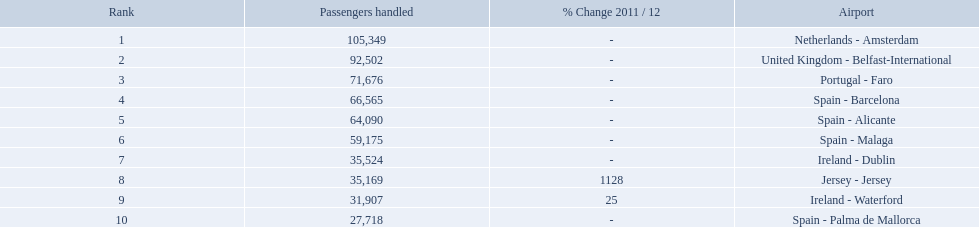What are the 10 busiest routes to and from london southend airport? Netherlands - Amsterdam, United Kingdom - Belfast-International, Portugal - Faro, Spain - Barcelona, Spain - Alicante, Spain - Malaga, Ireland - Dublin, Jersey - Jersey, Ireland - Waterford, Spain - Palma de Mallorca. Of these, which airport is in portugal? Portugal - Faro. 